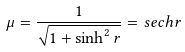Convert formula to latex. <formula><loc_0><loc_0><loc_500><loc_500>\mu = \frac { 1 } { \sqrt { 1 + \sinh ^ { 2 } r } } = s e c h r</formula> 